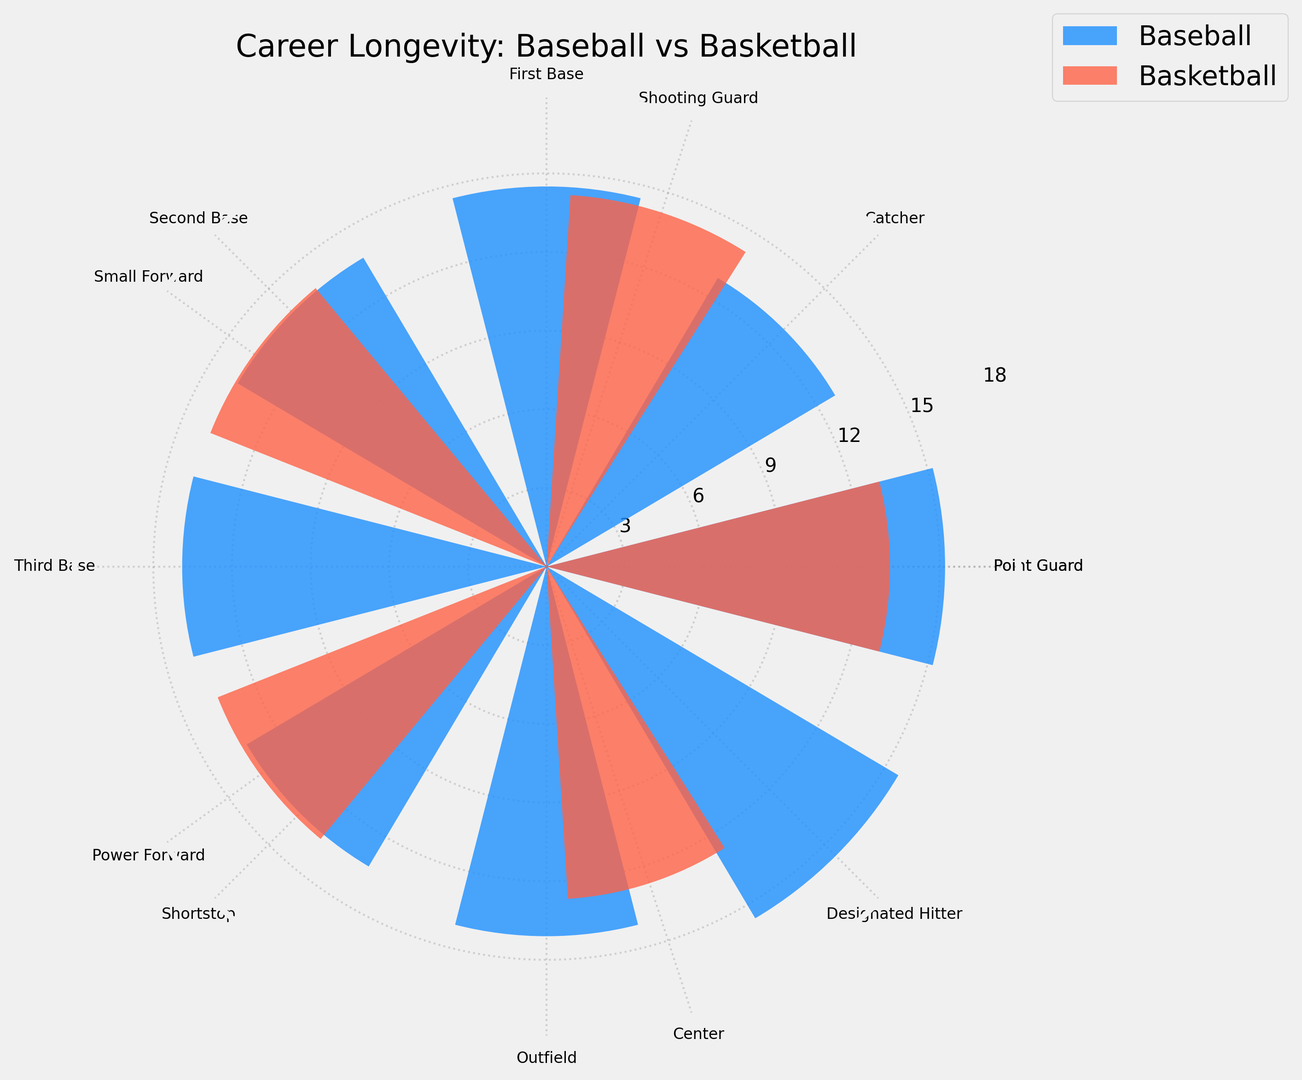Which position has the longest career in baseball? By examining the bar lengths for the baseball positions, we see that the Designated Hitter has the longest career at 15.6 years.
Answer: Designated Hitter When comparing the average career longevity of baseball and basketball players, which sport has the longer average career? Calculate the average for both sports: Baseball (15.2+12.8+14.5+13.7+13.9+13.3+14.1+15.6)/8 = 14.14 years, Basketball (13.1+14.2+13.8+13.5+12.7)/5 = 13.46 years. Baseball has a longer average career.
Answer: Baseball Which basketball position has the shortest career longevity? By looking at the bar lengths for the basketball positions, the Center has the shortest career at 12.7 years.
Answer: Center How many years longer is the career of the longest baseball position compared to the shortest basketball position? The longest baseball position is Designated Hitter at 15.6 years and the shortest basketball position is Center at 12.7 years. The difference is 15.6 - 12.7 = 2.9 years.
Answer: 2.9 years Which position in basketball has a career length closest to the First Base position in baseball? First Base in baseball is 14.5 years. The closest basketball position is the Shooting Guard at 14.2 years.
Answer: Shooting Guard Do any baseball positions have longer career longevity than the longest basketball position? The longest basketball position is the Shooting Guard at 14.2 years. Checking the baseball positions, Pitcher (15.2), Designated Hitter (15.6), Outfield (14.1) all have longer careers.
Answer: Yes What is the visual difference between the bar lengths of the Shortstop in baseball and the Small Forward in basketball? The length corresponds to the career years; Shortstop is 13.3 years and Small Forward is 13.8 years. Therefore, the bar for Small Forward is slightly longer.
Answer: Small Forward is slightly longer Are there more baseball positions or basketball positions depicted in the chart? Counting the labels for both sports, there are 8 baseball positions and 5 basketball positions depicted in the chart.
Answer: Baseball What is the combined career length of the Pitcher and the Point Guard? The Pitcher has a career length of 15.2 years and the Point Guard has 13.1 years. Adding them together: 15.2 + 13.1 = 28.3 years.
Answer: 28.3 years 